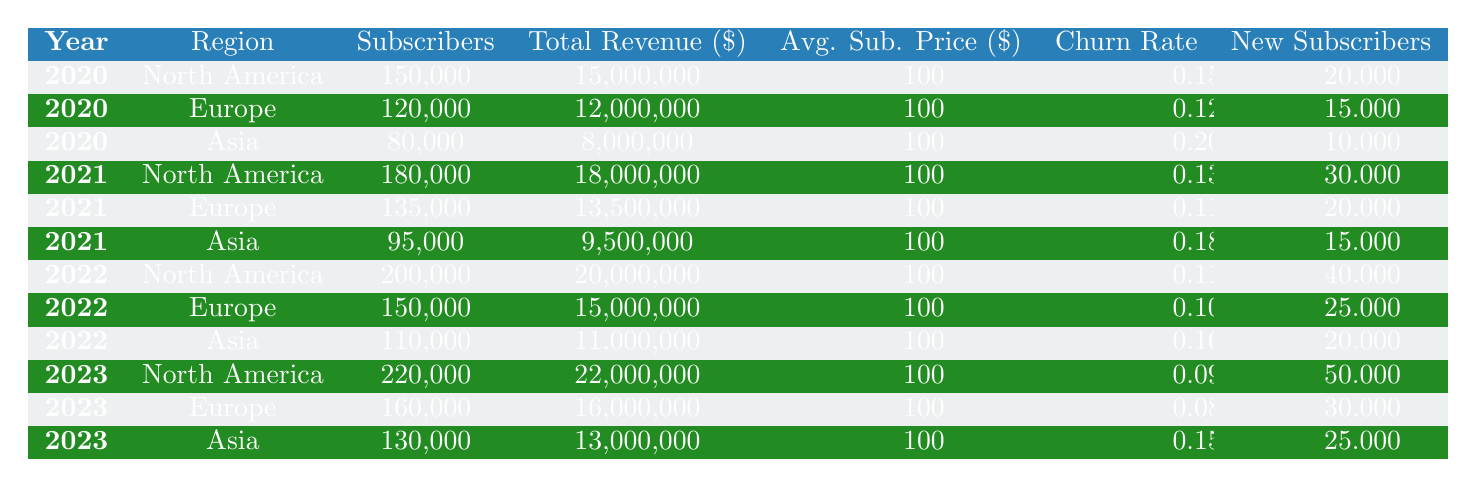What was the total revenue in Asia for 2021? The total revenue for Asia in 2021 is listed directly in the table, which shows a value of $9,500,000.
Answer: 9,500,000 Which region had the highest churn rate in 2020? By comparing the churn rates for each region in 2020, Asia has a churn rate of 0.20, which is higher than North America (0.15) and Europe (0.12).
Answer: Asia What is the average number of new subscribers for all regions in 2022? Adding the new subscribers for all regions in 2022 gives: 40,000 (North America) + 25,000 (Europe) + 20,000 (Asia) = 85,000. There are 3 regions, so the average is 85,000 / 3 = 28,333.
Answer: 28,333 Did North America experience a decrease in subscribers from 2021 to 2022? The subscribers in North America increased from 180,000 in 2021 to 200,000 in 2022, indicating an increase rather than a decrease.
Answer: No What was the total growth in subscribers from 2020 to 2023 for Europe? The number of subscribers in Europe increased from 120,000 in 2020 to 160,000 in 2023. The growth is 160,000 - 120,000 = 40,000.
Answer: 40,000 What is the average subscription price across all regions for all years? The average subscription price is consistent at $100 across all regions and years. Therefore, the average remains $100.
Answer: 100 Which year had the highest total revenue out of all regions combined? Calculating total revenue for each year: 2020 = $15M + $12M + $8M = $35M, 2021 = $18M + $13.5M + $9.5M = $41M, 2022 = $20M + $15M + $11M = $46M, 2023 = $22M + $16M + $13M = $51M. The highest is $51M in 2023.
Answer: 2023 What was the churn rate for Europe in 2023? The table directly indicates the churn rate for Europe in 2023 as 0.08.
Answer: 0.08 How many new subscribers did Asia gain between 2021 and 2022? The new subscribers in Asia were 15,000 in 2021 and 20,000 in 2022. The increase is 20,000 - 15,000 = 5,000.
Answer: 5,000 Is it true that North America had more subscribers in 2023 than Europe had in 2022? North America had 220,000 subscribers in 2023 while Europe had 150,000 in 2022, so the statement is true.
Answer: Yes 